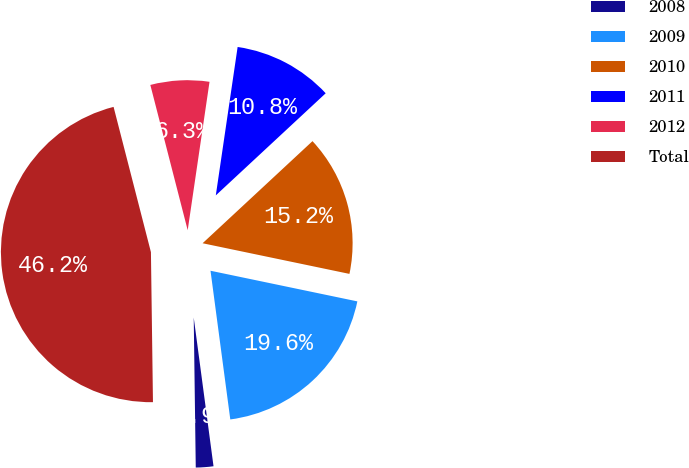Convert chart to OTSL. <chart><loc_0><loc_0><loc_500><loc_500><pie_chart><fcel>2008<fcel>2009<fcel>2010<fcel>2011<fcel>2012<fcel>Total<nl><fcel>1.89%<fcel>19.62%<fcel>15.19%<fcel>10.76%<fcel>6.33%<fcel>46.21%<nl></chart> 